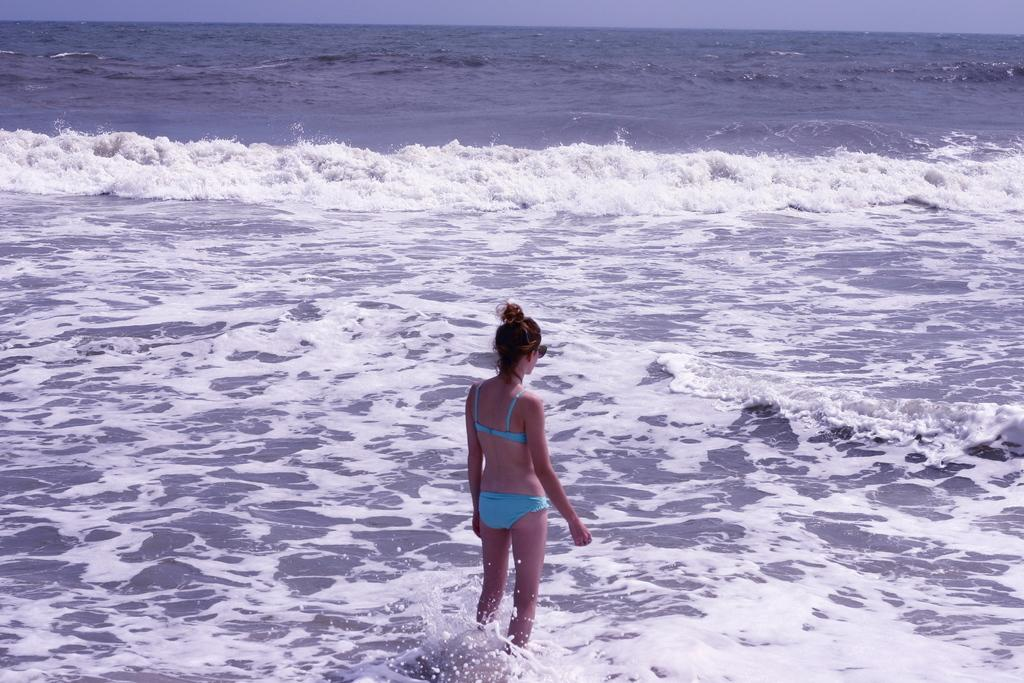What is the main subject of the image? The main subject of the image is a woman. Can you describe the woman's location in the image? The woman is standing in the water. What type of water body is the woman standing in? The water is part of a sea. Can you tell me how many snakes are slithering around the woman in the image? There are no snakes present in the image. What type of loss is the woman experiencing in the image? There is no indication of any loss in the image; it simply shows a woman standing in the water. Where is the stove located in the image? There is no stove present in the image. 